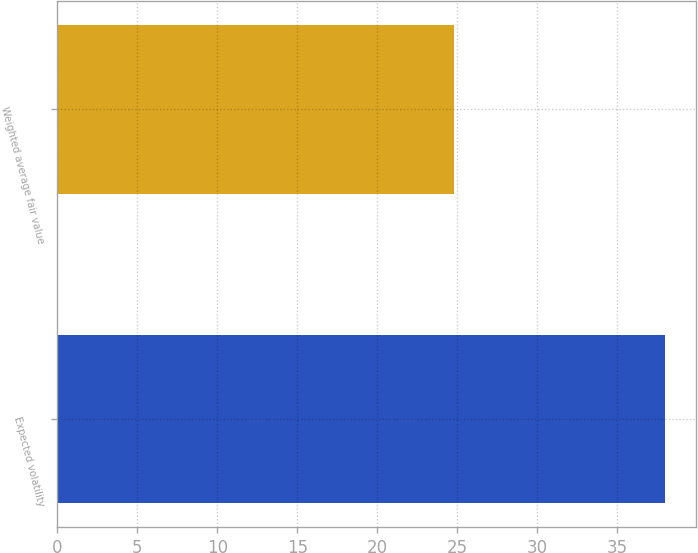Convert chart. <chart><loc_0><loc_0><loc_500><loc_500><bar_chart><fcel>Expected volatility<fcel>Weighted average fair value<nl><fcel>38<fcel>24.82<nl></chart> 